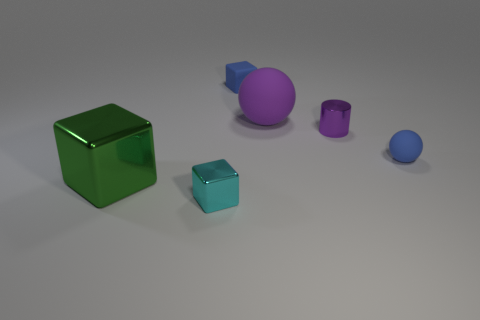Add 2 green objects. How many objects exist? 8 Subtract all balls. How many objects are left? 4 Subtract all green blocks. Subtract all purple things. How many objects are left? 3 Add 3 tiny matte balls. How many tiny matte balls are left? 4 Add 3 large cyan metallic cylinders. How many large cyan metallic cylinders exist? 3 Subtract 0 cyan cylinders. How many objects are left? 6 